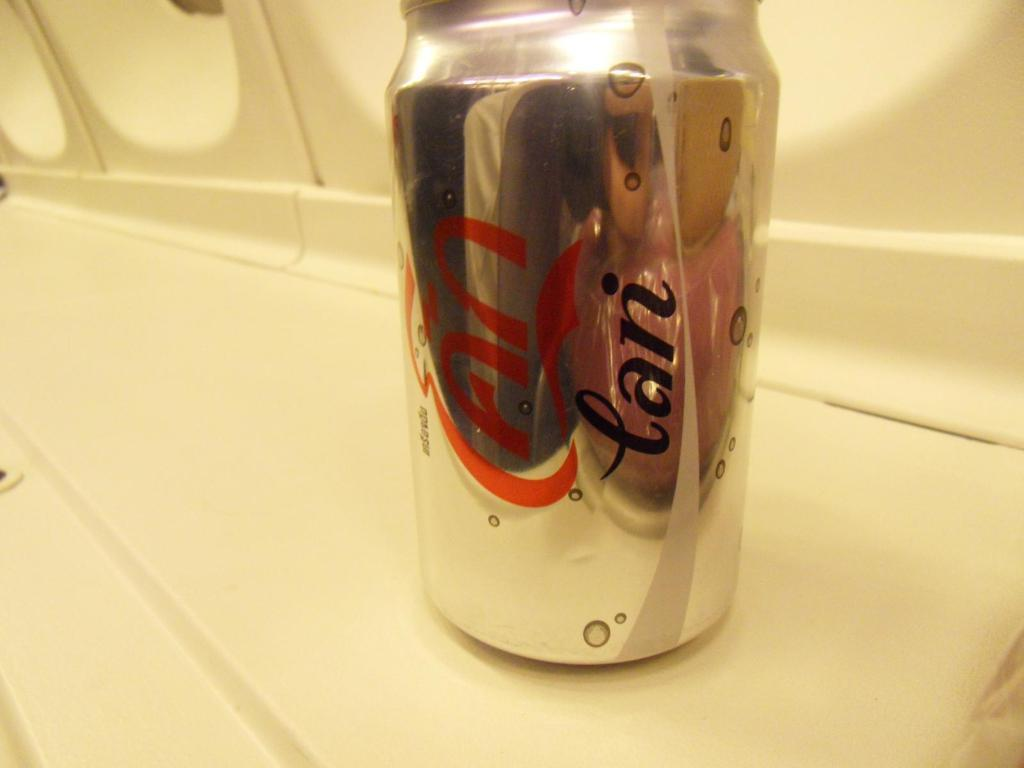<image>
Render a clear and concise summary of the photo. a can of soda that says can on it 